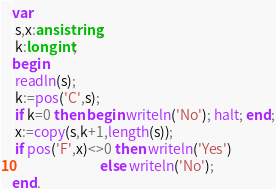<code> <loc_0><loc_0><loc_500><loc_500><_Pascal_>var
 s,x:ansistring; 
 k:longint;
begin
 readln(s);
 k:=pos('C',s);
 if k=0 then begin writeln('No'); halt; end;
 x:=copy(s,k+1,length(s));
 if pos('F',x)<>0 then writeln('Yes')
                            else writeln('No');
end.</code> 